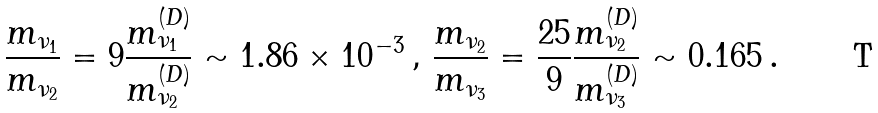Convert formula to latex. <formula><loc_0><loc_0><loc_500><loc_500>\frac { m _ { \nu _ { 1 } } } { m _ { \nu _ { 2 } } } = 9 \frac { m ^ { ( D ) } _ { \nu _ { 1 } } } { m ^ { ( D ) } _ { \nu _ { 2 } } } \sim 1 . 8 6 \times 1 0 ^ { - 3 } \, , \, \frac { m _ { \nu _ { 2 } } } { m _ { \nu _ { 3 } } } = \frac { 2 5 } { 9 } \frac { m ^ { ( D ) } _ { \nu _ { 2 } } } { m ^ { ( D ) } _ { \nu _ { 3 } } } \sim 0 . 1 6 5 \, .</formula> 